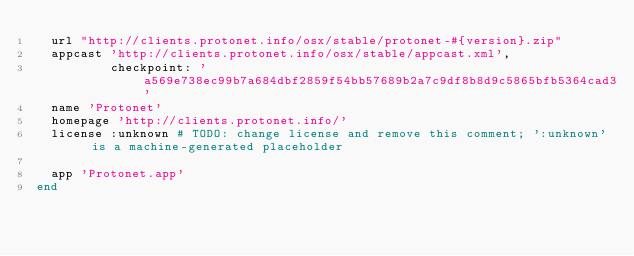Convert code to text. <code><loc_0><loc_0><loc_500><loc_500><_Ruby_>  url "http://clients.protonet.info/osx/stable/protonet-#{version}.zip"
  appcast 'http://clients.protonet.info/osx/stable/appcast.xml',
          checkpoint: 'a569e738ec99b7a684dbf2859f54bb57689b2a7c9df8b8d9c5865bfb5364cad3'
  name 'Protonet'
  homepage 'http://clients.protonet.info/'
  license :unknown # TODO: change license and remove this comment; ':unknown' is a machine-generated placeholder

  app 'Protonet.app'
end
</code> 